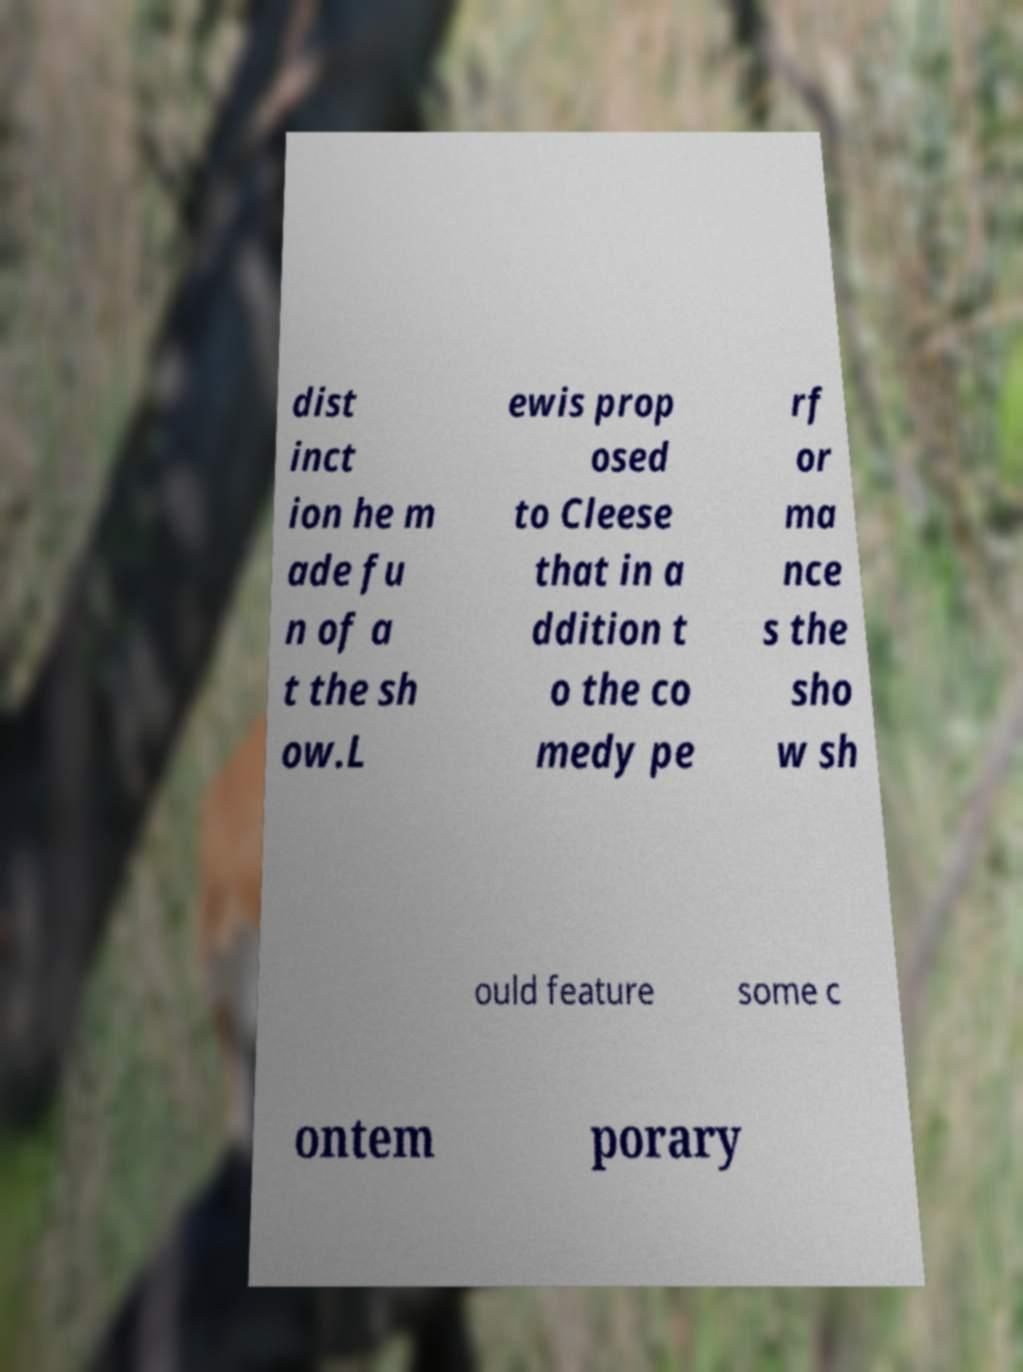Could you assist in decoding the text presented in this image and type it out clearly? dist inct ion he m ade fu n of a t the sh ow.L ewis prop osed to Cleese that in a ddition t o the co medy pe rf or ma nce s the sho w sh ould feature some c ontem porary 